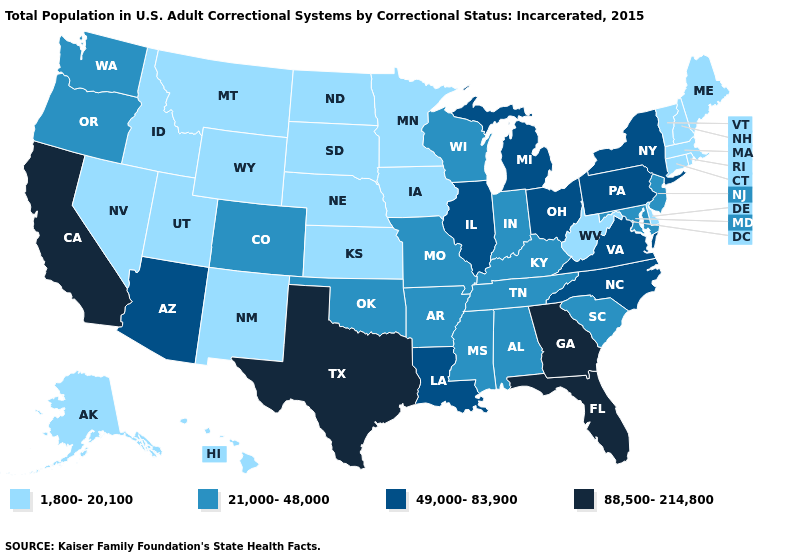Name the states that have a value in the range 49,000-83,900?
Answer briefly. Arizona, Illinois, Louisiana, Michigan, New York, North Carolina, Ohio, Pennsylvania, Virginia. Does Massachusetts have the highest value in the USA?
Answer briefly. No. Does Nebraska have the lowest value in the MidWest?
Quick response, please. Yes. What is the value of New Hampshire?
Short answer required. 1,800-20,100. What is the value of Alaska?
Quick response, please. 1,800-20,100. Which states have the lowest value in the USA?
Answer briefly. Alaska, Connecticut, Delaware, Hawaii, Idaho, Iowa, Kansas, Maine, Massachusetts, Minnesota, Montana, Nebraska, Nevada, New Hampshire, New Mexico, North Dakota, Rhode Island, South Dakota, Utah, Vermont, West Virginia, Wyoming. Name the states that have a value in the range 49,000-83,900?
Concise answer only. Arizona, Illinois, Louisiana, Michigan, New York, North Carolina, Ohio, Pennsylvania, Virginia. What is the value of North Dakota?
Short answer required. 1,800-20,100. Which states have the highest value in the USA?
Be succinct. California, Florida, Georgia, Texas. What is the value of New Jersey?
Short answer required. 21,000-48,000. Is the legend a continuous bar?
Answer briefly. No. Name the states that have a value in the range 49,000-83,900?
Keep it brief. Arizona, Illinois, Louisiana, Michigan, New York, North Carolina, Ohio, Pennsylvania, Virginia. Name the states that have a value in the range 1,800-20,100?
Short answer required. Alaska, Connecticut, Delaware, Hawaii, Idaho, Iowa, Kansas, Maine, Massachusetts, Minnesota, Montana, Nebraska, Nevada, New Hampshire, New Mexico, North Dakota, Rhode Island, South Dakota, Utah, Vermont, West Virginia, Wyoming. What is the value of California?
Concise answer only. 88,500-214,800. Which states hav the highest value in the Northeast?
Short answer required. New York, Pennsylvania. 